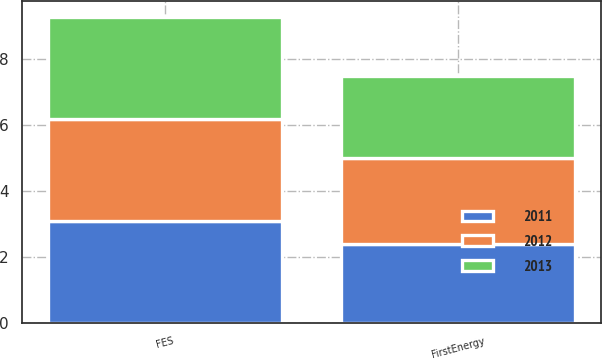Convert chart. <chart><loc_0><loc_0><loc_500><loc_500><stacked_bar_chart><ecel><fcel>FirstEnergy<fcel>FES<nl><fcel>2012<fcel>2.6<fcel>3.1<nl><fcel>2013<fcel>2.5<fcel>3.1<nl><fcel>2011<fcel>2.4<fcel>3.1<nl></chart> 